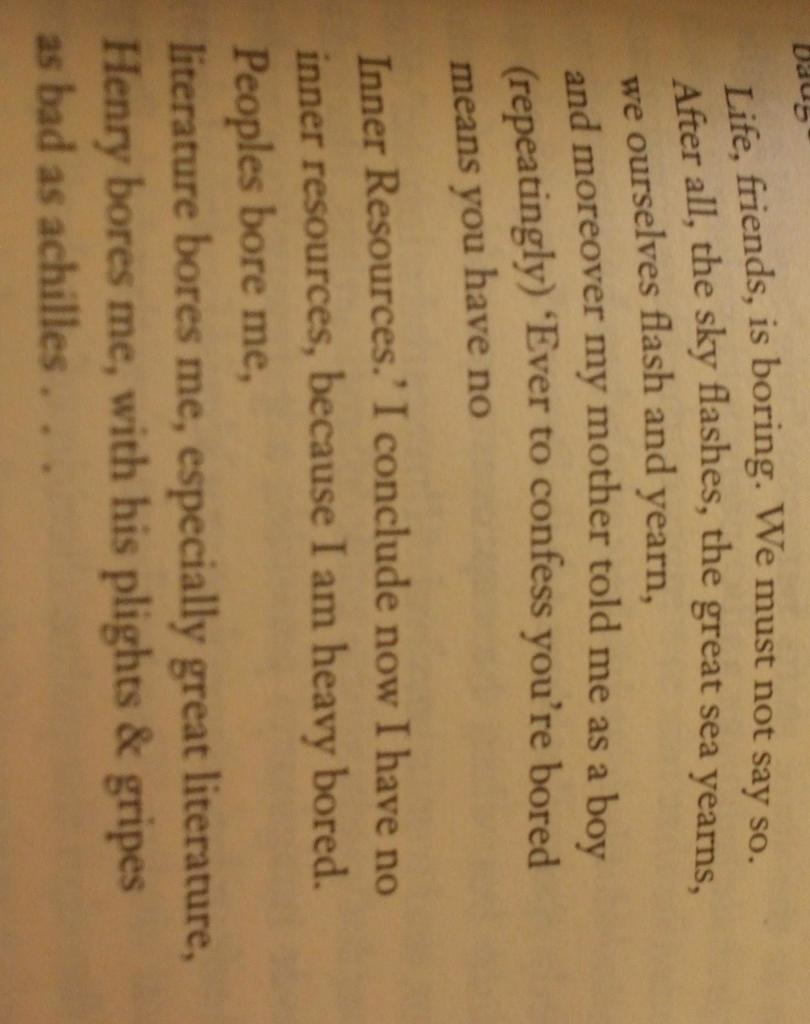<image>
Create a compact narrative representing the image presented. a page that starts with the words 'life, friends, is boring.' 